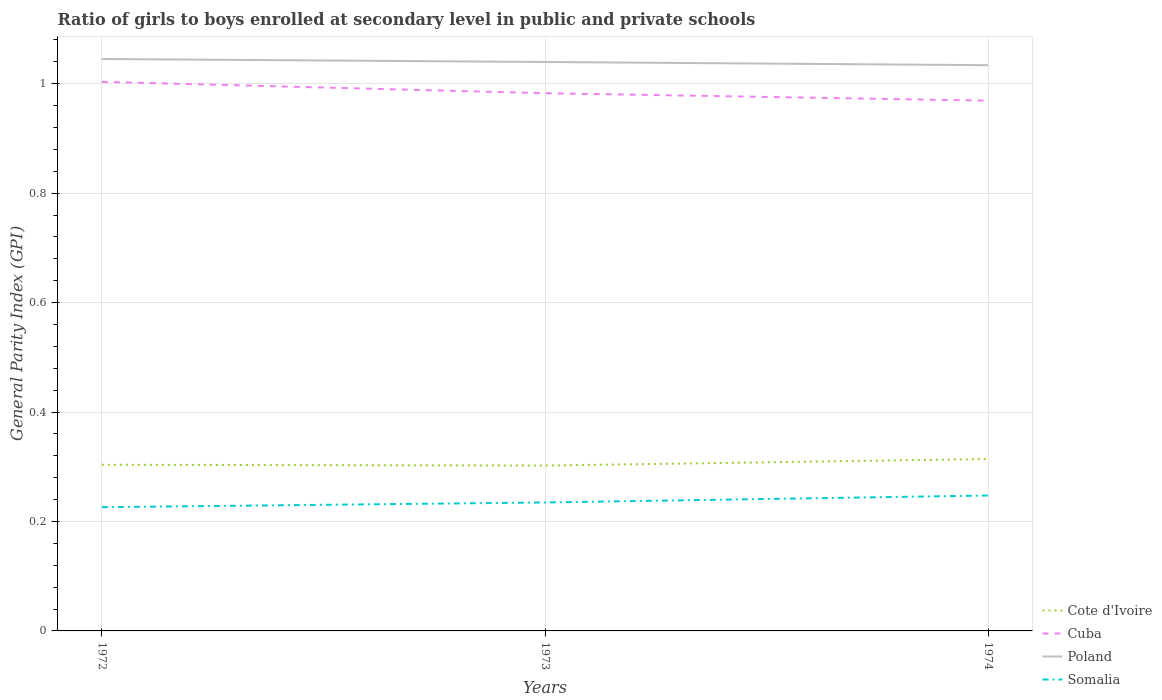How many different coloured lines are there?
Offer a terse response. 4. Does the line corresponding to Cuba intersect with the line corresponding to Somalia?
Ensure brevity in your answer.  No. Across all years, what is the maximum general parity index in Somalia?
Your answer should be compact. 0.23. In which year was the general parity index in Poland maximum?
Your answer should be compact. 1974. What is the total general parity index in Cuba in the graph?
Provide a succinct answer. 0.01. What is the difference between the highest and the second highest general parity index in Poland?
Offer a terse response. 0.01. Is the general parity index in Cote d'Ivoire strictly greater than the general parity index in Somalia over the years?
Provide a short and direct response. No. How many years are there in the graph?
Your answer should be compact. 3. What is the difference between two consecutive major ticks on the Y-axis?
Give a very brief answer. 0.2. How are the legend labels stacked?
Ensure brevity in your answer.  Vertical. What is the title of the graph?
Provide a short and direct response. Ratio of girls to boys enrolled at secondary level in public and private schools. What is the label or title of the X-axis?
Provide a succinct answer. Years. What is the label or title of the Y-axis?
Keep it short and to the point. General Parity Index (GPI). What is the General Parity Index (GPI) in Cote d'Ivoire in 1972?
Your answer should be very brief. 0.3. What is the General Parity Index (GPI) of Cuba in 1972?
Give a very brief answer. 1. What is the General Parity Index (GPI) of Poland in 1972?
Your response must be concise. 1.05. What is the General Parity Index (GPI) in Somalia in 1972?
Ensure brevity in your answer.  0.23. What is the General Parity Index (GPI) in Cote d'Ivoire in 1973?
Give a very brief answer. 0.3. What is the General Parity Index (GPI) of Cuba in 1973?
Provide a short and direct response. 0.98. What is the General Parity Index (GPI) of Poland in 1973?
Provide a succinct answer. 1.04. What is the General Parity Index (GPI) of Somalia in 1973?
Give a very brief answer. 0.23. What is the General Parity Index (GPI) in Cote d'Ivoire in 1974?
Give a very brief answer. 0.31. What is the General Parity Index (GPI) in Cuba in 1974?
Offer a very short reply. 0.97. What is the General Parity Index (GPI) of Poland in 1974?
Keep it short and to the point. 1.03. What is the General Parity Index (GPI) in Somalia in 1974?
Your answer should be compact. 0.25. Across all years, what is the maximum General Parity Index (GPI) in Cote d'Ivoire?
Offer a very short reply. 0.31. Across all years, what is the maximum General Parity Index (GPI) of Cuba?
Ensure brevity in your answer.  1. Across all years, what is the maximum General Parity Index (GPI) in Poland?
Offer a very short reply. 1.05. Across all years, what is the maximum General Parity Index (GPI) in Somalia?
Keep it short and to the point. 0.25. Across all years, what is the minimum General Parity Index (GPI) of Cote d'Ivoire?
Your answer should be compact. 0.3. Across all years, what is the minimum General Parity Index (GPI) in Cuba?
Provide a succinct answer. 0.97. Across all years, what is the minimum General Parity Index (GPI) of Poland?
Keep it short and to the point. 1.03. Across all years, what is the minimum General Parity Index (GPI) in Somalia?
Your answer should be compact. 0.23. What is the total General Parity Index (GPI) of Cuba in the graph?
Your answer should be very brief. 2.96. What is the total General Parity Index (GPI) of Poland in the graph?
Ensure brevity in your answer.  3.12. What is the total General Parity Index (GPI) of Somalia in the graph?
Your answer should be compact. 0.71. What is the difference between the General Parity Index (GPI) in Cote d'Ivoire in 1972 and that in 1973?
Make the answer very short. 0. What is the difference between the General Parity Index (GPI) of Cuba in 1972 and that in 1973?
Offer a terse response. 0.02. What is the difference between the General Parity Index (GPI) of Poland in 1972 and that in 1973?
Offer a terse response. 0.01. What is the difference between the General Parity Index (GPI) of Somalia in 1972 and that in 1973?
Ensure brevity in your answer.  -0.01. What is the difference between the General Parity Index (GPI) of Cote d'Ivoire in 1972 and that in 1974?
Make the answer very short. -0.01. What is the difference between the General Parity Index (GPI) in Cuba in 1972 and that in 1974?
Offer a terse response. 0.03. What is the difference between the General Parity Index (GPI) in Poland in 1972 and that in 1974?
Make the answer very short. 0.01. What is the difference between the General Parity Index (GPI) in Somalia in 1972 and that in 1974?
Ensure brevity in your answer.  -0.02. What is the difference between the General Parity Index (GPI) in Cote d'Ivoire in 1973 and that in 1974?
Offer a terse response. -0.01. What is the difference between the General Parity Index (GPI) in Cuba in 1973 and that in 1974?
Give a very brief answer. 0.01. What is the difference between the General Parity Index (GPI) in Poland in 1973 and that in 1974?
Offer a very short reply. 0.01. What is the difference between the General Parity Index (GPI) of Somalia in 1973 and that in 1974?
Ensure brevity in your answer.  -0.01. What is the difference between the General Parity Index (GPI) in Cote d'Ivoire in 1972 and the General Parity Index (GPI) in Cuba in 1973?
Your answer should be compact. -0.68. What is the difference between the General Parity Index (GPI) in Cote d'Ivoire in 1972 and the General Parity Index (GPI) in Poland in 1973?
Offer a terse response. -0.74. What is the difference between the General Parity Index (GPI) in Cote d'Ivoire in 1972 and the General Parity Index (GPI) in Somalia in 1973?
Your response must be concise. 0.07. What is the difference between the General Parity Index (GPI) in Cuba in 1972 and the General Parity Index (GPI) in Poland in 1973?
Offer a very short reply. -0.04. What is the difference between the General Parity Index (GPI) of Cuba in 1972 and the General Parity Index (GPI) of Somalia in 1973?
Make the answer very short. 0.77. What is the difference between the General Parity Index (GPI) of Poland in 1972 and the General Parity Index (GPI) of Somalia in 1973?
Your response must be concise. 0.81. What is the difference between the General Parity Index (GPI) of Cote d'Ivoire in 1972 and the General Parity Index (GPI) of Cuba in 1974?
Offer a very short reply. -0.67. What is the difference between the General Parity Index (GPI) in Cote d'Ivoire in 1972 and the General Parity Index (GPI) in Poland in 1974?
Keep it short and to the point. -0.73. What is the difference between the General Parity Index (GPI) of Cote d'Ivoire in 1972 and the General Parity Index (GPI) of Somalia in 1974?
Ensure brevity in your answer.  0.06. What is the difference between the General Parity Index (GPI) in Cuba in 1972 and the General Parity Index (GPI) in Poland in 1974?
Your answer should be compact. -0.03. What is the difference between the General Parity Index (GPI) of Cuba in 1972 and the General Parity Index (GPI) of Somalia in 1974?
Provide a succinct answer. 0.76. What is the difference between the General Parity Index (GPI) of Poland in 1972 and the General Parity Index (GPI) of Somalia in 1974?
Make the answer very short. 0.8. What is the difference between the General Parity Index (GPI) in Cote d'Ivoire in 1973 and the General Parity Index (GPI) in Cuba in 1974?
Ensure brevity in your answer.  -0.67. What is the difference between the General Parity Index (GPI) in Cote d'Ivoire in 1973 and the General Parity Index (GPI) in Poland in 1974?
Keep it short and to the point. -0.73. What is the difference between the General Parity Index (GPI) of Cote d'Ivoire in 1973 and the General Parity Index (GPI) of Somalia in 1974?
Keep it short and to the point. 0.05. What is the difference between the General Parity Index (GPI) in Cuba in 1973 and the General Parity Index (GPI) in Poland in 1974?
Your answer should be very brief. -0.05. What is the difference between the General Parity Index (GPI) of Cuba in 1973 and the General Parity Index (GPI) of Somalia in 1974?
Provide a short and direct response. 0.74. What is the difference between the General Parity Index (GPI) of Poland in 1973 and the General Parity Index (GPI) of Somalia in 1974?
Provide a short and direct response. 0.79. What is the average General Parity Index (GPI) in Cote d'Ivoire per year?
Give a very brief answer. 0.31. What is the average General Parity Index (GPI) of Cuba per year?
Make the answer very short. 0.99. What is the average General Parity Index (GPI) of Poland per year?
Your response must be concise. 1.04. What is the average General Parity Index (GPI) in Somalia per year?
Your answer should be compact. 0.24. In the year 1972, what is the difference between the General Parity Index (GPI) in Cote d'Ivoire and General Parity Index (GPI) in Cuba?
Ensure brevity in your answer.  -0.7. In the year 1972, what is the difference between the General Parity Index (GPI) in Cote d'Ivoire and General Parity Index (GPI) in Poland?
Your answer should be very brief. -0.74. In the year 1972, what is the difference between the General Parity Index (GPI) in Cote d'Ivoire and General Parity Index (GPI) in Somalia?
Keep it short and to the point. 0.08. In the year 1972, what is the difference between the General Parity Index (GPI) of Cuba and General Parity Index (GPI) of Poland?
Provide a succinct answer. -0.04. In the year 1972, what is the difference between the General Parity Index (GPI) of Cuba and General Parity Index (GPI) of Somalia?
Provide a short and direct response. 0.78. In the year 1972, what is the difference between the General Parity Index (GPI) in Poland and General Parity Index (GPI) in Somalia?
Give a very brief answer. 0.82. In the year 1973, what is the difference between the General Parity Index (GPI) of Cote d'Ivoire and General Parity Index (GPI) of Cuba?
Give a very brief answer. -0.68. In the year 1973, what is the difference between the General Parity Index (GPI) of Cote d'Ivoire and General Parity Index (GPI) of Poland?
Your answer should be compact. -0.74. In the year 1973, what is the difference between the General Parity Index (GPI) in Cote d'Ivoire and General Parity Index (GPI) in Somalia?
Provide a short and direct response. 0.07. In the year 1973, what is the difference between the General Parity Index (GPI) of Cuba and General Parity Index (GPI) of Poland?
Offer a terse response. -0.06. In the year 1973, what is the difference between the General Parity Index (GPI) in Cuba and General Parity Index (GPI) in Somalia?
Provide a short and direct response. 0.75. In the year 1973, what is the difference between the General Parity Index (GPI) of Poland and General Parity Index (GPI) of Somalia?
Provide a succinct answer. 0.81. In the year 1974, what is the difference between the General Parity Index (GPI) in Cote d'Ivoire and General Parity Index (GPI) in Cuba?
Make the answer very short. -0.65. In the year 1974, what is the difference between the General Parity Index (GPI) of Cote d'Ivoire and General Parity Index (GPI) of Poland?
Your response must be concise. -0.72. In the year 1974, what is the difference between the General Parity Index (GPI) of Cote d'Ivoire and General Parity Index (GPI) of Somalia?
Your response must be concise. 0.07. In the year 1974, what is the difference between the General Parity Index (GPI) of Cuba and General Parity Index (GPI) of Poland?
Provide a succinct answer. -0.06. In the year 1974, what is the difference between the General Parity Index (GPI) of Cuba and General Parity Index (GPI) of Somalia?
Your answer should be very brief. 0.72. In the year 1974, what is the difference between the General Parity Index (GPI) in Poland and General Parity Index (GPI) in Somalia?
Make the answer very short. 0.79. What is the ratio of the General Parity Index (GPI) of Cote d'Ivoire in 1972 to that in 1973?
Make the answer very short. 1. What is the ratio of the General Parity Index (GPI) in Cuba in 1972 to that in 1973?
Ensure brevity in your answer.  1.02. What is the ratio of the General Parity Index (GPI) of Somalia in 1972 to that in 1973?
Your answer should be very brief. 0.96. What is the ratio of the General Parity Index (GPI) in Cote d'Ivoire in 1972 to that in 1974?
Keep it short and to the point. 0.97. What is the ratio of the General Parity Index (GPI) of Cuba in 1972 to that in 1974?
Your answer should be very brief. 1.04. What is the ratio of the General Parity Index (GPI) of Somalia in 1972 to that in 1974?
Provide a succinct answer. 0.91. What is the ratio of the General Parity Index (GPI) of Cote d'Ivoire in 1973 to that in 1974?
Provide a short and direct response. 0.96. What is the ratio of the General Parity Index (GPI) in Cuba in 1973 to that in 1974?
Offer a terse response. 1.01. What is the ratio of the General Parity Index (GPI) in Poland in 1973 to that in 1974?
Provide a succinct answer. 1.01. What is the ratio of the General Parity Index (GPI) of Somalia in 1973 to that in 1974?
Provide a succinct answer. 0.95. What is the difference between the highest and the second highest General Parity Index (GPI) in Cote d'Ivoire?
Ensure brevity in your answer.  0.01. What is the difference between the highest and the second highest General Parity Index (GPI) of Cuba?
Your answer should be compact. 0.02. What is the difference between the highest and the second highest General Parity Index (GPI) of Poland?
Give a very brief answer. 0.01. What is the difference between the highest and the second highest General Parity Index (GPI) of Somalia?
Your response must be concise. 0.01. What is the difference between the highest and the lowest General Parity Index (GPI) of Cote d'Ivoire?
Offer a very short reply. 0.01. What is the difference between the highest and the lowest General Parity Index (GPI) of Cuba?
Offer a very short reply. 0.03. What is the difference between the highest and the lowest General Parity Index (GPI) in Poland?
Provide a succinct answer. 0.01. What is the difference between the highest and the lowest General Parity Index (GPI) of Somalia?
Make the answer very short. 0.02. 